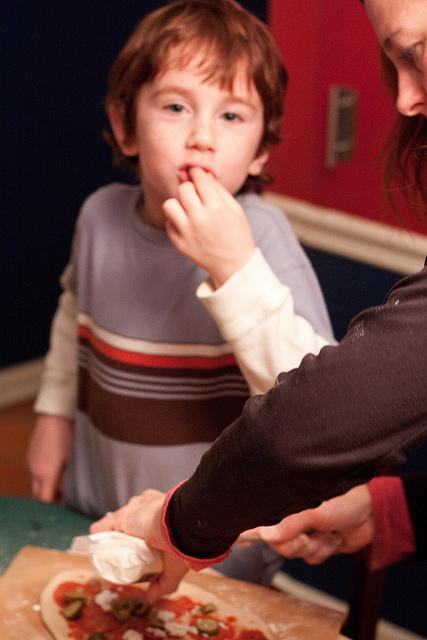Are there stripes on his t shirt?
Concise answer only. Yes. What are the boy and his mother doing?
Short answer required. Eating. Are both people wearing long sleeves?
Be succinct. Yes. 